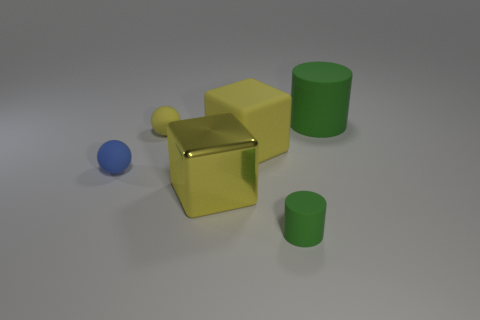There is a shiny thing that is the same color as the matte cube; what shape is it?
Provide a short and direct response. Cube. There is a metallic cube that is behind the cylinder that is on the left side of the big green matte cylinder; what color is it?
Offer a very short reply. Yellow. What material is the other large object that is the same shape as the big metallic object?
Offer a very short reply. Rubber. How many matte things are tiny blue balls or big yellow cubes?
Offer a terse response. 2. Are the yellow block that is behind the small blue thing and the small blue object left of the small cylinder made of the same material?
Your answer should be very brief. Yes. Is there a blue matte ball?
Make the answer very short. Yes. There is a small yellow thing behind the small blue matte thing; does it have the same shape as the tiny matte object that is in front of the big yellow shiny cube?
Provide a short and direct response. No. Is there a blue object that has the same material as the tiny green thing?
Provide a short and direct response. Yes. Does the large thing that is in front of the tiny blue matte thing have the same material as the large green object?
Provide a short and direct response. No. Are there more blocks on the right side of the yellow rubber block than small rubber objects that are in front of the large metal cube?
Your answer should be compact. No. 